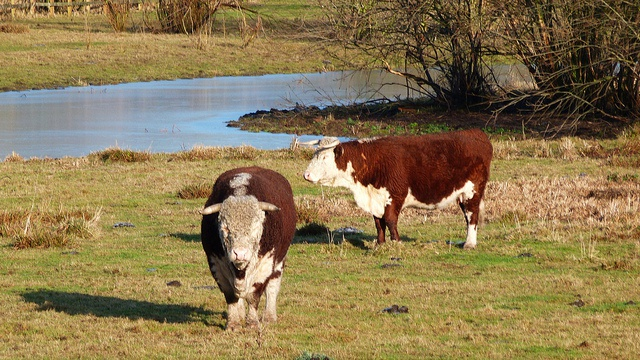Describe the objects in this image and their specific colors. I can see cow in tan, maroon, and beige tones and cow in tan, maroon, and black tones in this image. 